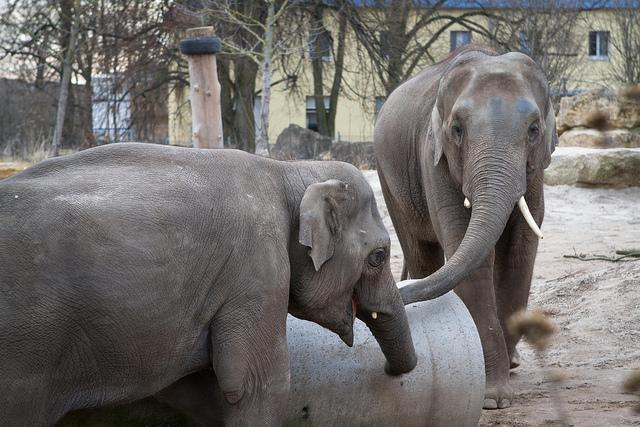How many elephants are there?
Give a very brief answer. 2. How many elephants can be seen?
Give a very brief answer. 2. 